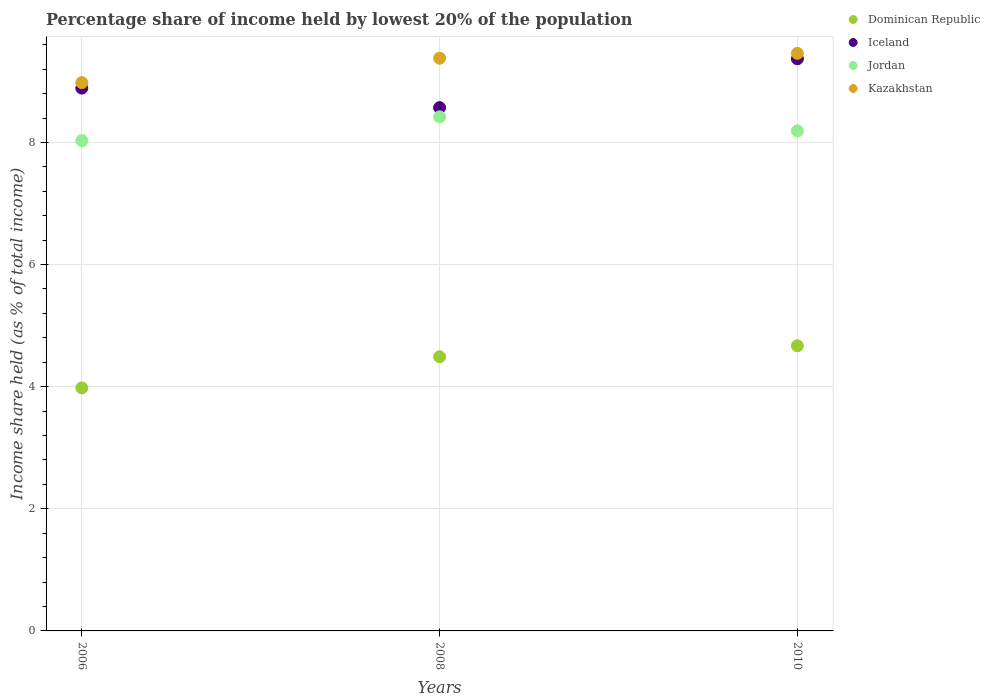Is the number of dotlines equal to the number of legend labels?
Your answer should be compact. Yes. What is the percentage share of income held by lowest 20% of the population in Kazakhstan in 2008?
Your answer should be very brief. 9.38. Across all years, what is the maximum percentage share of income held by lowest 20% of the population in Iceland?
Your answer should be compact. 9.37. Across all years, what is the minimum percentage share of income held by lowest 20% of the population in Jordan?
Your answer should be compact. 8.03. What is the total percentage share of income held by lowest 20% of the population in Dominican Republic in the graph?
Provide a succinct answer. 13.14. What is the difference between the percentage share of income held by lowest 20% of the population in Kazakhstan in 2006 and that in 2010?
Provide a short and direct response. -0.48. What is the difference between the percentage share of income held by lowest 20% of the population in Jordan in 2006 and the percentage share of income held by lowest 20% of the population in Dominican Republic in 2010?
Give a very brief answer. 3.36. What is the average percentage share of income held by lowest 20% of the population in Iceland per year?
Give a very brief answer. 8.94. In the year 2006, what is the difference between the percentage share of income held by lowest 20% of the population in Iceland and percentage share of income held by lowest 20% of the population in Kazakhstan?
Provide a succinct answer. -0.09. In how many years, is the percentage share of income held by lowest 20% of the population in Jordan greater than 8 %?
Make the answer very short. 3. What is the ratio of the percentage share of income held by lowest 20% of the population in Dominican Republic in 2008 to that in 2010?
Your response must be concise. 0.96. Is the difference between the percentage share of income held by lowest 20% of the population in Iceland in 2006 and 2010 greater than the difference between the percentage share of income held by lowest 20% of the population in Kazakhstan in 2006 and 2010?
Give a very brief answer. Yes. What is the difference between the highest and the second highest percentage share of income held by lowest 20% of the population in Iceland?
Offer a terse response. 0.48. What is the difference between the highest and the lowest percentage share of income held by lowest 20% of the population in Kazakhstan?
Provide a succinct answer. 0.48. In how many years, is the percentage share of income held by lowest 20% of the population in Iceland greater than the average percentage share of income held by lowest 20% of the population in Iceland taken over all years?
Offer a terse response. 1. Is the percentage share of income held by lowest 20% of the population in Kazakhstan strictly less than the percentage share of income held by lowest 20% of the population in Jordan over the years?
Offer a very short reply. No. What is the difference between two consecutive major ticks on the Y-axis?
Ensure brevity in your answer.  2. Where does the legend appear in the graph?
Your answer should be very brief. Top right. How many legend labels are there?
Your answer should be compact. 4. How are the legend labels stacked?
Your answer should be compact. Vertical. What is the title of the graph?
Provide a succinct answer. Percentage share of income held by lowest 20% of the population. Does "Montenegro" appear as one of the legend labels in the graph?
Provide a succinct answer. No. What is the label or title of the X-axis?
Keep it short and to the point. Years. What is the label or title of the Y-axis?
Make the answer very short. Income share held (as % of total income). What is the Income share held (as % of total income) of Dominican Republic in 2006?
Keep it short and to the point. 3.98. What is the Income share held (as % of total income) in Iceland in 2006?
Give a very brief answer. 8.89. What is the Income share held (as % of total income) in Jordan in 2006?
Your answer should be compact. 8.03. What is the Income share held (as % of total income) in Kazakhstan in 2006?
Make the answer very short. 8.98. What is the Income share held (as % of total income) in Dominican Republic in 2008?
Your answer should be very brief. 4.49. What is the Income share held (as % of total income) in Iceland in 2008?
Your answer should be very brief. 8.57. What is the Income share held (as % of total income) in Jordan in 2008?
Offer a very short reply. 8.42. What is the Income share held (as % of total income) of Kazakhstan in 2008?
Offer a very short reply. 9.38. What is the Income share held (as % of total income) in Dominican Republic in 2010?
Make the answer very short. 4.67. What is the Income share held (as % of total income) of Iceland in 2010?
Your response must be concise. 9.37. What is the Income share held (as % of total income) in Jordan in 2010?
Provide a short and direct response. 8.19. What is the Income share held (as % of total income) of Kazakhstan in 2010?
Your answer should be very brief. 9.46. Across all years, what is the maximum Income share held (as % of total income) in Dominican Republic?
Offer a very short reply. 4.67. Across all years, what is the maximum Income share held (as % of total income) in Iceland?
Your answer should be compact. 9.37. Across all years, what is the maximum Income share held (as % of total income) of Jordan?
Your answer should be very brief. 8.42. Across all years, what is the maximum Income share held (as % of total income) of Kazakhstan?
Your answer should be compact. 9.46. Across all years, what is the minimum Income share held (as % of total income) in Dominican Republic?
Your response must be concise. 3.98. Across all years, what is the minimum Income share held (as % of total income) of Iceland?
Offer a terse response. 8.57. Across all years, what is the minimum Income share held (as % of total income) of Jordan?
Make the answer very short. 8.03. Across all years, what is the minimum Income share held (as % of total income) of Kazakhstan?
Offer a very short reply. 8.98. What is the total Income share held (as % of total income) of Dominican Republic in the graph?
Your answer should be very brief. 13.14. What is the total Income share held (as % of total income) in Iceland in the graph?
Your response must be concise. 26.83. What is the total Income share held (as % of total income) of Jordan in the graph?
Ensure brevity in your answer.  24.64. What is the total Income share held (as % of total income) in Kazakhstan in the graph?
Your response must be concise. 27.82. What is the difference between the Income share held (as % of total income) of Dominican Republic in 2006 and that in 2008?
Your answer should be compact. -0.51. What is the difference between the Income share held (as % of total income) of Iceland in 2006 and that in 2008?
Provide a succinct answer. 0.32. What is the difference between the Income share held (as % of total income) in Jordan in 2006 and that in 2008?
Ensure brevity in your answer.  -0.39. What is the difference between the Income share held (as % of total income) of Dominican Republic in 2006 and that in 2010?
Your response must be concise. -0.69. What is the difference between the Income share held (as % of total income) of Iceland in 2006 and that in 2010?
Keep it short and to the point. -0.48. What is the difference between the Income share held (as % of total income) in Jordan in 2006 and that in 2010?
Provide a succinct answer. -0.16. What is the difference between the Income share held (as % of total income) of Kazakhstan in 2006 and that in 2010?
Provide a short and direct response. -0.48. What is the difference between the Income share held (as % of total income) of Dominican Republic in 2008 and that in 2010?
Keep it short and to the point. -0.18. What is the difference between the Income share held (as % of total income) in Iceland in 2008 and that in 2010?
Make the answer very short. -0.8. What is the difference between the Income share held (as % of total income) of Jordan in 2008 and that in 2010?
Ensure brevity in your answer.  0.23. What is the difference between the Income share held (as % of total income) in Kazakhstan in 2008 and that in 2010?
Ensure brevity in your answer.  -0.08. What is the difference between the Income share held (as % of total income) of Dominican Republic in 2006 and the Income share held (as % of total income) of Iceland in 2008?
Offer a very short reply. -4.59. What is the difference between the Income share held (as % of total income) of Dominican Republic in 2006 and the Income share held (as % of total income) of Jordan in 2008?
Your response must be concise. -4.44. What is the difference between the Income share held (as % of total income) in Dominican Republic in 2006 and the Income share held (as % of total income) in Kazakhstan in 2008?
Offer a very short reply. -5.4. What is the difference between the Income share held (as % of total income) of Iceland in 2006 and the Income share held (as % of total income) of Jordan in 2008?
Offer a terse response. 0.47. What is the difference between the Income share held (as % of total income) of Iceland in 2006 and the Income share held (as % of total income) of Kazakhstan in 2008?
Ensure brevity in your answer.  -0.49. What is the difference between the Income share held (as % of total income) in Jordan in 2006 and the Income share held (as % of total income) in Kazakhstan in 2008?
Your answer should be compact. -1.35. What is the difference between the Income share held (as % of total income) of Dominican Republic in 2006 and the Income share held (as % of total income) of Iceland in 2010?
Offer a very short reply. -5.39. What is the difference between the Income share held (as % of total income) of Dominican Republic in 2006 and the Income share held (as % of total income) of Jordan in 2010?
Your answer should be compact. -4.21. What is the difference between the Income share held (as % of total income) of Dominican Republic in 2006 and the Income share held (as % of total income) of Kazakhstan in 2010?
Make the answer very short. -5.48. What is the difference between the Income share held (as % of total income) in Iceland in 2006 and the Income share held (as % of total income) in Jordan in 2010?
Your answer should be compact. 0.7. What is the difference between the Income share held (as % of total income) of Iceland in 2006 and the Income share held (as % of total income) of Kazakhstan in 2010?
Give a very brief answer. -0.57. What is the difference between the Income share held (as % of total income) in Jordan in 2006 and the Income share held (as % of total income) in Kazakhstan in 2010?
Offer a very short reply. -1.43. What is the difference between the Income share held (as % of total income) of Dominican Republic in 2008 and the Income share held (as % of total income) of Iceland in 2010?
Provide a short and direct response. -4.88. What is the difference between the Income share held (as % of total income) in Dominican Republic in 2008 and the Income share held (as % of total income) in Jordan in 2010?
Offer a very short reply. -3.7. What is the difference between the Income share held (as % of total income) in Dominican Republic in 2008 and the Income share held (as % of total income) in Kazakhstan in 2010?
Ensure brevity in your answer.  -4.97. What is the difference between the Income share held (as % of total income) in Iceland in 2008 and the Income share held (as % of total income) in Jordan in 2010?
Ensure brevity in your answer.  0.38. What is the difference between the Income share held (as % of total income) of Iceland in 2008 and the Income share held (as % of total income) of Kazakhstan in 2010?
Your response must be concise. -0.89. What is the difference between the Income share held (as % of total income) of Jordan in 2008 and the Income share held (as % of total income) of Kazakhstan in 2010?
Make the answer very short. -1.04. What is the average Income share held (as % of total income) of Dominican Republic per year?
Offer a very short reply. 4.38. What is the average Income share held (as % of total income) in Iceland per year?
Keep it short and to the point. 8.94. What is the average Income share held (as % of total income) of Jordan per year?
Provide a short and direct response. 8.21. What is the average Income share held (as % of total income) in Kazakhstan per year?
Your response must be concise. 9.27. In the year 2006, what is the difference between the Income share held (as % of total income) of Dominican Republic and Income share held (as % of total income) of Iceland?
Your answer should be compact. -4.91. In the year 2006, what is the difference between the Income share held (as % of total income) of Dominican Republic and Income share held (as % of total income) of Jordan?
Your response must be concise. -4.05. In the year 2006, what is the difference between the Income share held (as % of total income) of Dominican Republic and Income share held (as % of total income) of Kazakhstan?
Your answer should be compact. -5. In the year 2006, what is the difference between the Income share held (as % of total income) in Iceland and Income share held (as % of total income) in Jordan?
Keep it short and to the point. 0.86. In the year 2006, what is the difference between the Income share held (as % of total income) in Iceland and Income share held (as % of total income) in Kazakhstan?
Your answer should be compact. -0.09. In the year 2006, what is the difference between the Income share held (as % of total income) in Jordan and Income share held (as % of total income) in Kazakhstan?
Ensure brevity in your answer.  -0.95. In the year 2008, what is the difference between the Income share held (as % of total income) in Dominican Republic and Income share held (as % of total income) in Iceland?
Offer a terse response. -4.08. In the year 2008, what is the difference between the Income share held (as % of total income) of Dominican Republic and Income share held (as % of total income) of Jordan?
Ensure brevity in your answer.  -3.93. In the year 2008, what is the difference between the Income share held (as % of total income) of Dominican Republic and Income share held (as % of total income) of Kazakhstan?
Offer a terse response. -4.89. In the year 2008, what is the difference between the Income share held (as % of total income) of Iceland and Income share held (as % of total income) of Kazakhstan?
Give a very brief answer. -0.81. In the year 2008, what is the difference between the Income share held (as % of total income) of Jordan and Income share held (as % of total income) of Kazakhstan?
Your response must be concise. -0.96. In the year 2010, what is the difference between the Income share held (as % of total income) in Dominican Republic and Income share held (as % of total income) in Iceland?
Your response must be concise. -4.7. In the year 2010, what is the difference between the Income share held (as % of total income) in Dominican Republic and Income share held (as % of total income) in Jordan?
Offer a terse response. -3.52. In the year 2010, what is the difference between the Income share held (as % of total income) in Dominican Republic and Income share held (as % of total income) in Kazakhstan?
Your answer should be compact. -4.79. In the year 2010, what is the difference between the Income share held (as % of total income) in Iceland and Income share held (as % of total income) in Jordan?
Give a very brief answer. 1.18. In the year 2010, what is the difference between the Income share held (as % of total income) in Iceland and Income share held (as % of total income) in Kazakhstan?
Provide a succinct answer. -0.09. In the year 2010, what is the difference between the Income share held (as % of total income) of Jordan and Income share held (as % of total income) of Kazakhstan?
Your response must be concise. -1.27. What is the ratio of the Income share held (as % of total income) in Dominican Republic in 2006 to that in 2008?
Provide a succinct answer. 0.89. What is the ratio of the Income share held (as % of total income) in Iceland in 2006 to that in 2008?
Keep it short and to the point. 1.04. What is the ratio of the Income share held (as % of total income) of Jordan in 2006 to that in 2008?
Provide a short and direct response. 0.95. What is the ratio of the Income share held (as % of total income) in Kazakhstan in 2006 to that in 2008?
Your answer should be compact. 0.96. What is the ratio of the Income share held (as % of total income) of Dominican Republic in 2006 to that in 2010?
Your response must be concise. 0.85. What is the ratio of the Income share held (as % of total income) in Iceland in 2006 to that in 2010?
Provide a succinct answer. 0.95. What is the ratio of the Income share held (as % of total income) in Jordan in 2006 to that in 2010?
Your answer should be compact. 0.98. What is the ratio of the Income share held (as % of total income) of Kazakhstan in 2006 to that in 2010?
Give a very brief answer. 0.95. What is the ratio of the Income share held (as % of total income) of Dominican Republic in 2008 to that in 2010?
Offer a terse response. 0.96. What is the ratio of the Income share held (as % of total income) in Iceland in 2008 to that in 2010?
Your response must be concise. 0.91. What is the ratio of the Income share held (as % of total income) in Jordan in 2008 to that in 2010?
Provide a succinct answer. 1.03. What is the ratio of the Income share held (as % of total income) in Kazakhstan in 2008 to that in 2010?
Your answer should be compact. 0.99. What is the difference between the highest and the second highest Income share held (as % of total income) of Dominican Republic?
Give a very brief answer. 0.18. What is the difference between the highest and the second highest Income share held (as % of total income) of Iceland?
Give a very brief answer. 0.48. What is the difference between the highest and the second highest Income share held (as % of total income) of Jordan?
Ensure brevity in your answer.  0.23. What is the difference between the highest and the second highest Income share held (as % of total income) in Kazakhstan?
Your response must be concise. 0.08. What is the difference between the highest and the lowest Income share held (as % of total income) of Dominican Republic?
Your answer should be compact. 0.69. What is the difference between the highest and the lowest Income share held (as % of total income) of Iceland?
Your answer should be very brief. 0.8. What is the difference between the highest and the lowest Income share held (as % of total income) in Jordan?
Keep it short and to the point. 0.39. What is the difference between the highest and the lowest Income share held (as % of total income) of Kazakhstan?
Your response must be concise. 0.48. 